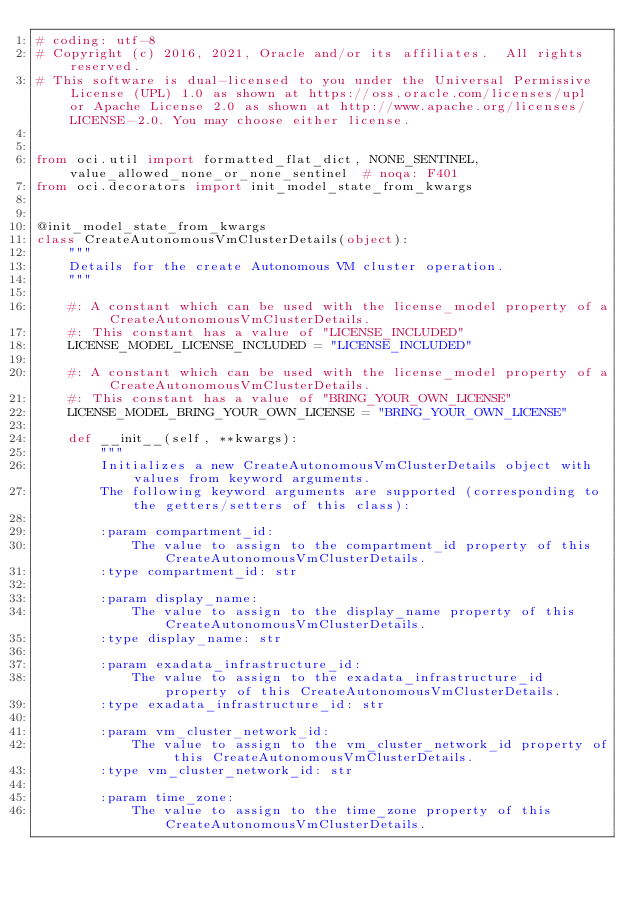<code> <loc_0><loc_0><loc_500><loc_500><_Python_># coding: utf-8
# Copyright (c) 2016, 2021, Oracle and/or its affiliates.  All rights reserved.
# This software is dual-licensed to you under the Universal Permissive License (UPL) 1.0 as shown at https://oss.oracle.com/licenses/upl or Apache License 2.0 as shown at http://www.apache.org/licenses/LICENSE-2.0. You may choose either license.


from oci.util import formatted_flat_dict, NONE_SENTINEL, value_allowed_none_or_none_sentinel  # noqa: F401
from oci.decorators import init_model_state_from_kwargs


@init_model_state_from_kwargs
class CreateAutonomousVmClusterDetails(object):
    """
    Details for the create Autonomous VM cluster operation.
    """

    #: A constant which can be used with the license_model property of a CreateAutonomousVmClusterDetails.
    #: This constant has a value of "LICENSE_INCLUDED"
    LICENSE_MODEL_LICENSE_INCLUDED = "LICENSE_INCLUDED"

    #: A constant which can be used with the license_model property of a CreateAutonomousVmClusterDetails.
    #: This constant has a value of "BRING_YOUR_OWN_LICENSE"
    LICENSE_MODEL_BRING_YOUR_OWN_LICENSE = "BRING_YOUR_OWN_LICENSE"

    def __init__(self, **kwargs):
        """
        Initializes a new CreateAutonomousVmClusterDetails object with values from keyword arguments.
        The following keyword arguments are supported (corresponding to the getters/setters of this class):

        :param compartment_id:
            The value to assign to the compartment_id property of this CreateAutonomousVmClusterDetails.
        :type compartment_id: str

        :param display_name:
            The value to assign to the display_name property of this CreateAutonomousVmClusterDetails.
        :type display_name: str

        :param exadata_infrastructure_id:
            The value to assign to the exadata_infrastructure_id property of this CreateAutonomousVmClusterDetails.
        :type exadata_infrastructure_id: str

        :param vm_cluster_network_id:
            The value to assign to the vm_cluster_network_id property of this CreateAutonomousVmClusterDetails.
        :type vm_cluster_network_id: str

        :param time_zone:
            The value to assign to the time_zone property of this CreateAutonomousVmClusterDetails.</code> 